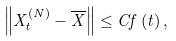Convert formula to latex. <formula><loc_0><loc_0><loc_500><loc_500>\left \| X _ { t } ^ { \left ( N \right ) } - \overline { X } \right \| \leq C f \left ( t \right ) ,</formula> 